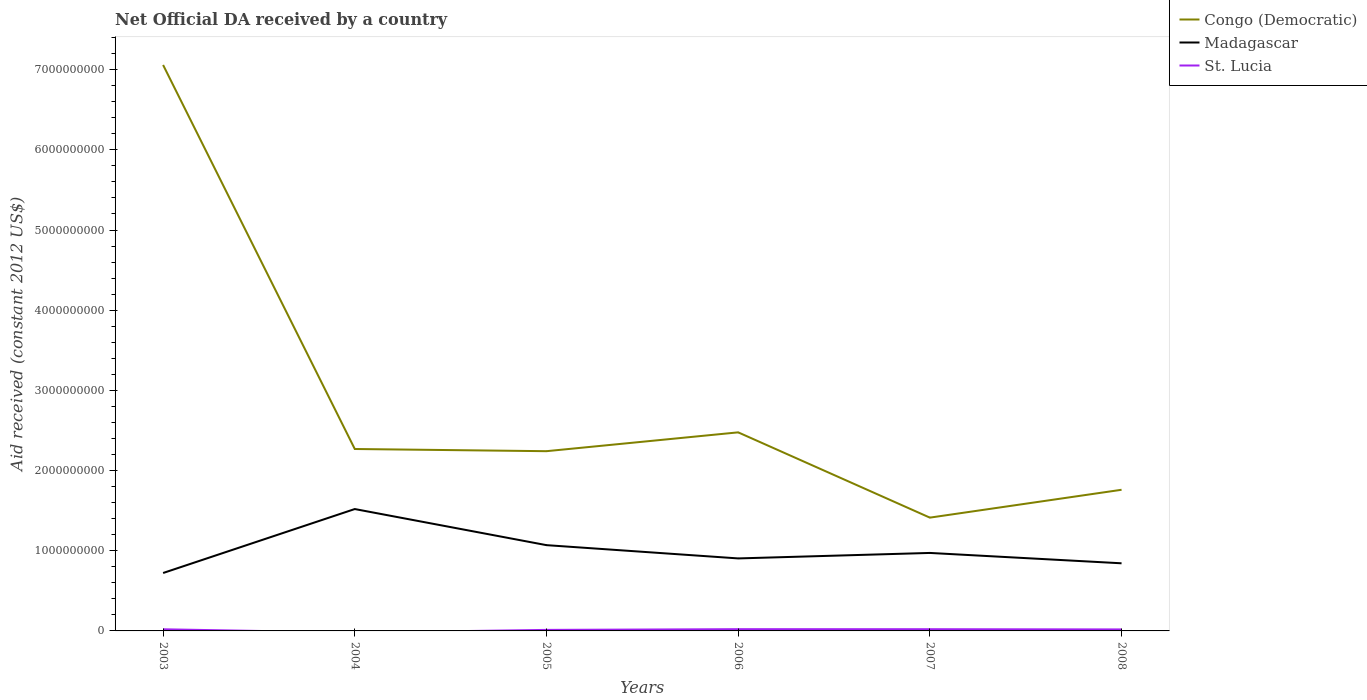How many different coloured lines are there?
Your answer should be compact. 3. Is the number of lines equal to the number of legend labels?
Give a very brief answer. No. Across all years, what is the maximum net official development assistance aid received in Madagascar?
Make the answer very short. 7.22e+08. What is the total net official development assistance aid received in Congo (Democratic) in the graph?
Offer a terse response. 4.79e+09. What is the difference between the highest and the second highest net official development assistance aid received in St. Lucia?
Provide a short and direct response. 2.18e+07. How many years are there in the graph?
Ensure brevity in your answer.  6. What is the difference between two consecutive major ticks on the Y-axis?
Give a very brief answer. 1.00e+09. Are the values on the major ticks of Y-axis written in scientific E-notation?
Keep it short and to the point. No. Where does the legend appear in the graph?
Keep it short and to the point. Top right. How many legend labels are there?
Offer a terse response. 3. How are the legend labels stacked?
Provide a short and direct response. Vertical. What is the title of the graph?
Provide a short and direct response. Net Official DA received by a country. What is the label or title of the Y-axis?
Provide a short and direct response. Aid received (constant 2012 US$). What is the Aid received (constant 2012 US$) in Congo (Democratic) in 2003?
Ensure brevity in your answer.  7.06e+09. What is the Aid received (constant 2012 US$) of Madagascar in 2003?
Offer a terse response. 7.22e+08. What is the Aid received (constant 2012 US$) of St. Lucia in 2003?
Offer a terse response. 2.05e+07. What is the Aid received (constant 2012 US$) of Congo (Democratic) in 2004?
Your answer should be very brief. 2.27e+09. What is the Aid received (constant 2012 US$) of Madagascar in 2004?
Your response must be concise. 1.52e+09. What is the Aid received (constant 2012 US$) of Congo (Democratic) in 2005?
Ensure brevity in your answer.  2.24e+09. What is the Aid received (constant 2012 US$) in Madagascar in 2005?
Make the answer very short. 1.07e+09. What is the Aid received (constant 2012 US$) in St. Lucia in 2005?
Provide a short and direct response. 1.29e+07. What is the Aid received (constant 2012 US$) of Congo (Democratic) in 2006?
Your answer should be compact. 2.48e+09. What is the Aid received (constant 2012 US$) in Madagascar in 2006?
Your response must be concise. 9.04e+08. What is the Aid received (constant 2012 US$) in St. Lucia in 2006?
Provide a short and direct response. 2.18e+07. What is the Aid received (constant 2012 US$) in Congo (Democratic) in 2007?
Ensure brevity in your answer.  1.41e+09. What is the Aid received (constant 2012 US$) of Madagascar in 2007?
Make the answer very short. 9.73e+08. What is the Aid received (constant 2012 US$) in St. Lucia in 2007?
Provide a succinct answer. 2.13e+07. What is the Aid received (constant 2012 US$) in Congo (Democratic) in 2008?
Make the answer very short. 1.76e+09. What is the Aid received (constant 2012 US$) of Madagascar in 2008?
Keep it short and to the point. 8.43e+08. What is the Aid received (constant 2012 US$) in St. Lucia in 2008?
Provide a short and direct response. 1.87e+07. Across all years, what is the maximum Aid received (constant 2012 US$) in Congo (Democratic)?
Ensure brevity in your answer.  7.06e+09. Across all years, what is the maximum Aid received (constant 2012 US$) of Madagascar?
Give a very brief answer. 1.52e+09. Across all years, what is the maximum Aid received (constant 2012 US$) of St. Lucia?
Make the answer very short. 2.18e+07. Across all years, what is the minimum Aid received (constant 2012 US$) in Congo (Democratic)?
Provide a succinct answer. 1.41e+09. Across all years, what is the minimum Aid received (constant 2012 US$) in Madagascar?
Keep it short and to the point. 7.22e+08. What is the total Aid received (constant 2012 US$) in Congo (Democratic) in the graph?
Offer a terse response. 1.72e+1. What is the total Aid received (constant 2012 US$) of Madagascar in the graph?
Ensure brevity in your answer.  6.03e+09. What is the total Aid received (constant 2012 US$) in St. Lucia in the graph?
Offer a terse response. 9.53e+07. What is the difference between the Aid received (constant 2012 US$) of Congo (Democratic) in 2003 and that in 2004?
Your response must be concise. 4.79e+09. What is the difference between the Aid received (constant 2012 US$) of Madagascar in 2003 and that in 2004?
Make the answer very short. -7.98e+08. What is the difference between the Aid received (constant 2012 US$) in Congo (Democratic) in 2003 and that in 2005?
Ensure brevity in your answer.  4.82e+09. What is the difference between the Aid received (constant 2012 US$) in Madagascar in 2003 and that in 2005?
Your response must be concise. -3.47e+08. What is the difference between the Aid received (constant 2012 US$) of St. Lucia in 2003 and that in 2005?
Offer a terse response. 7.64e+06. What is the difference between the Aid received (constant 2012 US$) in Congo (Democratic) in 2003 and that in 2006?
Your response must be concise. 4.58e+09. What is the difference between the Aid received (constant 2012 US$) of Madagascar in 2003 and that in 2006?
Provide a short and direct response. -1.82e+08. What is the difference between the Aid received (constant 2012 US$) of St. Lucia in 2003 and that in 2006?
Your response must be concise. -1.27e+06. What is the difference between the Aid received (constant 2012 US$) in Congo (Democratic) in 2003 and that in 2007?
Offer a terse response. 5.65e+09. What is the difference between the Aid received (constant 2012 US$) in Madagascar in 2003 and that in 2007?
Offer a terse response. -2.50e+08. What is the difference between the Aid received (constant 2012 US$) in St. Lucia in 2003 and that in 2007?
Give a very brief answer. -8.00e+05. What is the difference between the Aid received (constant 2012 US$) of Congo (Democratic) in 2003 and that in 2008?
Keep it short and to the point. 5.30e+09. What is the difference between the Aid received (constant 2012 US$) of Madagascar in 2003 and that in 2008?
Offer a terse response. -1.21e+08. What is the difference between the Aid received (constant 2012 US$) in St. Lucia in 2003 and that in 2008?
Your response must be concise. 1.85e+06. What is the difference between the Aid received (constant 2012 US$) in Congo (Democratic) in 2004 and that in 2005?
Provide a succinct answer. 2.72e+07. What is the difference between the Aid received (constant 2012 US$) in Madagascar in 2004 and that in 2005?
Offer a very short reply. 4.50e+08. What is the difference between the Aid received (constant 2012 US$) in Congo (Democratic) in 2004 and that in 2006?
Offer a very short reply. -2.08e+08. What is the difference between the Aid received (constant 2012 US$) in Madagascar in 2004 and that in 2006?
Give a very brief answer. 6.16e+08. What is the difference between the Aid received (constant 2012 US$) of Congo (Democratic) in 2004 and that in 2007?
Provide a short and direct response. 8.56e+08. What is the difference between the Aid received (constant 2012 US$) in Madagascar in 2004 and that in 2007?
Keep it short and to the point. 5.47e+08. What is the difference between the Aid received (constant 2012 US$) of Congo (Democratic) in 2004 and that in 2008?
Your response must be concise. 5.09e+08. What is the difference between the Aid received (constant 2012 US$) of Madagascar in 2004 and that in 2008?
Offer a terse response. 6.77e+08. What is the difference between the Aid received (constant 2012 US$) of Congo (Democratic) in 2005 and that in 2006?
Give a very brief answer. -2.35e+08. What is the difference between the Aid received (constant 2012 US$) of Madagascar in 2005 and that in 2006?
Offer a terse response. 1.65e+08. What is the difference between the Aid received (constant 2012 US$) of St. Lucia in 2005 and that in 2006?
Give a very brief answer. -8.91e+06. What is the difference between the Aid received (constant 2012 US$) of Congo (Democratic) in 2005 and that in 2007?
Provide a succinct answer. 8.29e+08. What is the difference between the Aid received (constant 2012 US$) of Madagascar in 2005 and that in 2007?
Make the answer very short. 9.71e+07. What is the difference between the Aid received (constant 2012 US$) of St. Lucia in 2005 and that in 2007?
Ensure brevity in your answer.  -8.44e+06. What is the difference between the Aid received (constant 2012 US$) in Congo (Democratic) in 2005 and that in 2008?
Keep it short and to the point. 4.81e+08. What is the difference between the Aid received (constant 2012 US$) in Madagascar in 2005 and that in 2008?
Provide a succinct answer. 2.26e+08. What is the difference between the Aid received (constant 2012 US$) of St. Lucia in 2005 and that in 2008?
Ensure brevity in your answer.  -5.79e+06. What is the difference between the Aid received (constant 2012 US$) in Congo (Democratic) in 2006 and that in 2007?
Ensure brevity in your answer.  1.06e+09. What is the difference between the Aid received (constant 2012 US$) in Madagascar in 2006 and that in 2007?
Your answer should be compact. -6.84e+07. What is the difference between the Aid received (constant 2012 US$) in Congo (Democratic) in 2006 and that in 2008?
Make the answer very short. 7.16e+08. What is the difference between the Aid received (constant 2012 US$) of Madagascar in 2006 and that in 2008?
Provide a succinct answer. 6.08e+07. What is the difference between the Aid received (constant 2012 US$) of St. Lucia in 2006 and that in 2008?
Offer a very short reply. 3.12e+06. What is the difference between the Aid received (constant 2012 US$) in Congo (Democratic) in 2007 and that in 2008?
Your response must be concise. -3.47e+08. What is the difference between the Aid received (constant 2012 US$) of Madagascar in 2007 and that in 2008?
Your answer should be very brief. 1.29e+08. What is the difference between the Aid received (constant 2012 US$) of St. Lucia in 2007 and that in 2008?
Give a very brief answer. 2.65e+06. What is the difference between the Aid received (constant 2012 US$) of Congo (Democratic) in 2003 and the Aid received (constant 2012 US$) of Madagascar in 2004?
Provide a succinct answer. 5.54e+09. What is the difference between the Aid received (constant 2012 US$) of Congo (Democratic) in 2003 and the Aid received (constant 2012 US$) of Madagascar in 2005?
Keep it short and to the point. 5.99e+09. What is the difference between the Aid received (constant 2012 US$) of Congo (Democratic) in 2003 and the Aid received (constant 2012 US$) of St. Lucia in 2005?
Offer a terse response. 7.05e+09. What is the difference between the Aid received (constant 2012 US$) of Madagascar in 2003 and the Aid received (constant 2012 US$) of St. Lucia in 2005?
Your answer should be very brief. 7.10e+08. What is the difference between the Aid received (constant 2012 US$) in Congo (Democratic) in 2003 and the Aid received (constant 2012 US$) in Madagascar in 2006?
Your answer should be compact. 6.15e+09. What is the difference between the Aid received (constant 2012 US$) of Congo (Democratic) in 2003 and the Aid received (constant 2012 US$) of St. Lucia in 2006?
Give a very brief answer. 7.04e+09. What is the difference between the Aid received (constant 2012 US$) in Madagascar in 2003 and the Aid received (constant 2012 US$) in St. Lucia in 2006?
Provide a succinct answer. 7.01e+08. What is the difference between the Aid received (constant 2012 US$) in Congo (Democratic) in 2003 and the Aid received (constant 2012 US$) in Madagascar in 2007?
Your response must be concise. 6.09e+09. What is the difference between the Aid received (constant 2012 US$) of Congo (Democratic) in 2003 and the Aid received (constant 2012 US$) of St. Lucia in 2007?
Your response must be concise. 7.04e+09. What is the difference between the Aid received (constant 2012 US$) in Madagascar in 2003 and the Aid received (constant 2012 US$) in St. Lucia in 2007?
Your response must be concise. 7.01e+08. What is the difference between the Aid received (constant 2012 US$) in Congo (Democratic) in 2003 and the Aid received (constant 2012 US$) in Madagascar in 2008?
Your response must be concise. 6.22e+09. What is the difference between the Aid received (constant 2012 US$) of Congo (Democratic) in 2003 and the Aid received (constant 2012 US$) of St. Lucia in 2008?
Your answer should be very brief. 7.04e+09. What is the difference between the Aid received (constant 2012 US$) in Madagascar in 2003 and the Aid received (constant 2012 US$) in St. Lucia in 2008?
Provide a short and direct response. 7.04e+08. What is the difference between the Aid received (constant 2012 US$) of Congo (Democratic) in 2004 and the Aid received (constant 2012 US$) of Madagascar in 2005?
Offer a terse response. 1.20e+09. What is the difference between the Aid received (constant 2012 US$) in Congo (Democratic) in 2004 and the Aid received (constant 2012 US$) in St. Lucia in 2005?
Ensure brevity in your answer.  2.26e+09. What is the difference between the Aid received (constant 2012 US$) in Madagascar in 2004 and the Aid received (constant 2012 US$) in St. Lucia in 2005?
Your answer should be very brief. 1.51e+09. What is the difference between the Aid received (constant 2012 US$) in Congo (Democratic) in 2004 and the Aid received (constant 2012 US$) in Madagascar in 2006?
Ensure brevity in your answer.  1.36e+09. What is the difference between the Aid received (constant 2012 US$) in Congo (Democratic) in 2004 and the Aid received (constant 2012 US$) in St. Lucia in 2006?
Make the answer very short. 2.25e+09. What is the difference between the Aid received (constant 2012 US$) in Madagascar in 2004 and the Aid received (constant 2012 US$) in St. Lucia in 2006?
Offer a terse response. 1.50e+09. What is the difference between the Aid received (constant 2012 US$) in Congo (Democratic) in 2004 and the Aid received (constant 2012 US$) in Madagascar in 2007?
Keep it short and to the point. 1.30e+09. What is the difference between the Aid received (constant 2012 US$) of Congo (Democratic) in 2004 and the Aid received (constant 2012 US$) of St. Lucia in 2007?
Offer a terse response. 2.25e+09. What is the difference between the Aid received (constant 2012 US$) of Madagascar in 2004 and the Aid received (constant 2012 US$) of St. Lucia in 2007?
Give a very brief answer. 1.50e+09. What is the difference between the Aid received (constant 2012 US$) in Congo (Democratic) in 2004 and the Aid received (constant 2012 US$) in Madagascar in 2008?
Provide a short and direct response. 1.43e+09. What is the difference between the Aid received (constant 2012 US$) in Congo (Democratic) in 2004 and the Aid received (constant 2012 US$) in St. Lucia in 2008?
Offer a very short reply. 2.25e+09. What is the difference between the Aid received (constant 2012 US$) of Madagascar in 2004 and the Aid received (constant 2012 US$) of St. Lucia in 2008?
Ensure brevity in your answer.  1.50e+09. What is the difference between the Aid received (constant 2012 US$) in Congo (Democratic) in 2005 and the Aid received (constant 2012 US$) in Madagascar in 2006?
Provide a short and direct response. 1.34e+09. What is the difference between the Aid received (constant 2012 US$) in Congo (Democratic) in 2005 and the Aid received (constant 2012 US$) in St. Lucia in 2006?
Provide a succinct answer. 2.22e+09. What is the difference between the Aid received (constant 2012 US$) in Madagascar in 2005 and the Aid received (constant 2012 US$) in St. Lucia in 2006?
Provide a short and direct response. 1.05e+09. What is the difference between the Aid received (constant 2012 US$) of Congo (Democratic) in 2005 and the Aid received (constant 2012 US$) of Madagascar in 2007?
Provide a succinct answer. 1.27e+09. What is the difference between the Aid received (constant 2012 US$) of Congo (Democratic) in 2005 and the Aid received (constant 2012 US$) of St. Lucia in 2007?
Your answer should be compact. 2.22e+09. What is the difference between the Aid received (constant 2012 US$) of Madagascar in 2005 and the Aid received (constant 2012 US$) of St. Lucia in 2007?
Your response must be concise. 1.05e+09. What is the difference between the Aid received (constant 2012 US$) of Congo (Democratic) in 2005 and the Aid received (constant 2012 US$) of Madagascar in 2008?
Your answer should be very brief. 1.40e+09. What is the difference between the Aid received (constant 2012 US$) of Congo (Democratic) in 2005 and the Aid received (constant 2012 US$) of St. Lucia in 2008?
Keep it short and to the point. 2.22e+09. What is the difference between the Aid received (constant 2012 US$) in Madagascar in 2005 and the Aid received (constant 2012 US$) in St. Lucia in 2008?
Offer a terse response. 1.05e+09. What is the difference between the Aid received (constant 2012 US$) of Congo (Democratic) in 2006 and the Aid received (constant 2012 US$) of Madagascar in 2007?
Offer a terse response. 1.50e+09. What is the difference between the Aid received (constant 2012 US$) of Congo (Democratic) in 2006 and the Aid received (constant 2012 US$) of St. Lucia in 2007?
Ensure brevity in your answer.  2.46e+09. What is the difference between the Aid received (constant 2012 US$) in Madagascar in 2006 and the Aid received (constant 2012 US$) in St. Lucia in 2007?
Ensure brevity in your answer.  8.83e+08. What is the difference between the Aid received (constant 2012 US$) in Congo (Democratic) in 2006 and the Aid received (constant 2012 US$) in Madagascar in 2008?
Offer a very short reply. 1.63e+09. What is the difference between the Aid received (constant 2012 US$) in Congo (Democratic) in 2006 and the Aid received (constant 2012 US$) in St. Lucia in 2008?
Your response must be concise. 2.46e+09. What is the difference between the Aid received (constant 2012 US$) in Madagascar in 2006 and the Aid received (constant 2012 US$) in St. Lucia in 2008?
Offer a very short reply. 8.86e+08. What is the difference between the Aid received (constant 2012 US$) in Congo (Democratic) in 2007 and the Aid received (constant 2012 US$) in Madagascar in 2008?
Your response must be concise. 5.70e+08. What is the difference between the Aid received (constant 2012 US$) in Congo (Democratic) in 2007 and the Aid received (constant 2012 US$) in St. Lucia in 2008?
Your answer should be compact. 1.39e+09. What is the difference between the Aid received (constant 2012 US$) in Madagascar in 2007 and the Aid received (constant 2012 US$) in St. Lucia in 2008?
Your answer should be very brief. 9.54e+08. What is the average Aid received (constant 2012 US$) of Congo (Democratic) per year?
Your response must be concise. 2.87e+09. What is the average Aid received (constant 2012 US$) in Madagascar per year?
Your answer should be very brief. 1.01e+09. What is the average Aid received (constant 2012 US$) in St. Lucia per year?
Make the answer very short. 1.59e+07. In the year 2003, what is the difference between the Aid received (constant 2012 US$) in Congo (Democratic) and Aid received (constant 2012 US$) in Madagascar?
Offer a very short reply. 6.34e+09. In the year 2003, what is the difference between the Aid received (constant 2012 US$) in Congo (Democratic) and Aid received (constant 2012 US$) in St. Lucia?
Provide a short and direct response. 7.04e+09. In the year 2003, what is the difference between the Aid received (constant 2012 US$) in Madagascar and Aid received (constant 2012 US$) in St. Lucia?
Offer a terse response. 7.02e+08. In the year 2004, what is the difference between the Aid received (constant 2012 US$) in Congo (Democratic) and Aid received (constant 2012 US$) in Madagascar?
Offer a terse response. 7.49e+08. In the year 2005, what is the difference between the Aid received (constant 2012 US$) of Congo (Democratic) and Aid received (constant 2012 US$) of Madagascar?
Your answer should be compact. 1.17e+09. In the year 2005, what is the difference between the Aid received (constant 2012 US$) in Congo (Democratic) and Aid received (constant 2012 US$) in St. Lucia?
Give a very brief answer. 2.23e+09. In the year 2005, what is the difference between the Aid received (constant 2012 US$) in Madagascar and Aid received (constant 2012 US$) in St. Lucia?
Your answer should be very brief. 1.06e+09. In the year 2006, what is the difference between the Aid received (constant 2012 US$) of Congo (Democratic) and Aid received (constant 2012 US$) of Madagascar?
Your answer should be very brief. 1.57e+09. In the year 2006, what is the difference between the Aid received (constant 2012 US$) in Congo (Democratic) and Aid received (constant 2012 US$) in St. Lucia?
Make the answer very short. 2.45e+09. In the year 2006, what is the difference between the Aid received (constant 2012 US$) in Madagascar and Aid received (constant 2012 US$) in St. Lucia?
Your response must be concise. 8.82e+08. In the year 2007, what is the difference between the Aid received (constant 2012 US$) of Congo (Democratic) and Aid received (constant 2012 US$) of Madagascar?
Make the answer very short. 4.40e+08. In the year 2007, what is the difference between the Aid received (constant 2012 US$) of Congo (Democratic) and Aid received (constant 2012 US$) of St. Lucia?
Make the answer very short. 1.39e+09. In the year 2007, what is the difference between the Aid received (constant 2012 US$) in Madagascar and Aid received (constant 2012 US$) in St. Lucia?
Give a very brief answer. 9.51e+08. In the year 2008, what is the difference between the Aid received (constant 2012 US$) in Congo (Democratic) and Aid received (constant 2012 US$) in Madagascar?
Make the answer very short. 9.17e+08. In the year 2008, what is the difference between the Aid received (constant 2012 US$) in Congo (Democratic) and Aid received (constant 2012 US$) in St. Lucia?
Your response must be concise. 1.74e+09. In the year 2008, what is the difference between the Aid received (constant 2012 US$) in Madagascar and Aid received (constant 2012 US$) in St. Lucia?
Your answer should be very brief. 8.25e+08. What is the ratio of the Aid received (constant 2012 US$) of Congo (Democratic) in 2003 to that in 2004?
Keep it short and to the point. 3.11. What is the ratio of the Aid received (constant 2012 US$) of Madagascar in 2003 to that in 2004?
Your answer should be very brief. 0.48. What is the ratio of the Aid received (constant 2012 US$) in Congo (Democratic) in 2003 to that in 2005?
Provide a short and direct response. 3.15. What is the ratio of the Aid received (constant 2012 US$) of Madagascar in 2003 to that in 2005?
Provide a short and direct response. 0.68. What is the ratio of the Aid received (constant 2012 US$) of St. Lucia in 2003 to that in 2005?
Your response must be concise. 1.59. What is the ratio of the Aid received (constant 2012 US$) of Congo (Democratic) in 2003 to that in 2006?
Provide a succinct answer. 2.85. What is the ratio of the Aid received (constant 2012 US$) of Madagascar in 2003 to that in 2006?
Offer a very short reply. 0.8. What is the ratio of the Aid received (constant 2012 US$) in St. Lucia in 2003 to that in 2006?
Offer a terse response. 0.94. What is the ratio of the Aid received (constant 2012 US$) in Congo (Democratic) in 2003 to that in 2007?
Provide a short and direct response. 5. What is the ratio of the Aid received (constant 2012 US$) of Madagascar in 2003 to that in 2007?
Give a very brief answer. 0.74. What is the ratio of the Aid received (constant 2012 US$) of St. Lucia in 2003 to that in 2007?
Your answer should be very brief. 0.96. What is the ratio of the Aid received (constant 2012 US$) in Congo (Democratic) in 2003 to that in 2008?
Provide a succinct answer. 4.01. What is the ratio of the Aid received (constant 2012 US$) in Madagascar in 2003 to that in 2008?
Ensure brevity in your answer.  0.86. What is the ratio of the Aid received (constant 2012 US$) of St. Lucia in 2003 to that in 2008?
Keep it short and to the point. 1.1. What is the ratio of the Aid received (constant 2012 US$) of Congo (Democratic) in 2004 to that in 2005?
Make the answer very short. 1.01. What is the ratio of the Aid received (constant 2012 US$) in Madagascar in 2004 to that in 2005?
Your response must be concise. 1.42. What is the ratio of the Aid received (constant 2012 US$) of Congo (Democratic) in 2004 to that in 2006?
Ensure brevity in your answer.  0.92. What is the ratio of the Aid received (constant 2012 US$) of Madagascar in 2004 to that in 2006?
Your response must be concise. 1.68. What is the ratio of the Aid received (constant 2012 US$) of Congo (Democratic) in 2004 to that in 2007?
Offer a terse response. 1.61. What is the ratio of the Aid received (constant 2012 US$) in Madagascar in 2004 to that in 2007?
Your response must be concise. 1.56. What is the ratio of the Aid received (constant 2012 US$) in Congo (Democratic) in 2004 to that in 2008?
Make the answer very short. 1.29. What is the ratio of the Aid received (constant 2012 US$) of Madagascar in 2004 to that in 2008?
Your response must be concise. 1.8. What is the ratio of the Aid received (constant 2012 US$) of Congo (Democratic) in 2005 to that in 2006?
Provide a succinct answer. 0.91. What is the ratio of the Aid received (constant 2012 US$) of Madagascar in 2005 to that in 2006?
Your response must be concise. 1.18. What is the ratio of the Aid received (constant 2012 US$) of St. Lucia in 2005 to that in 2006?
Ensure brevity in your answer.  0.59. What is the ratio of the Aid received (constant 2012 US$) of Congo (Democratic) in 2005 to that in 2007?
Keep it short and to the point. 1.59. What is the ratio of the Aid received (constant 2012 US$) in Madagascar in 2005 to that in 2007?
Provide a short and direct response. 1.1. What is the ratio of the Aid received (constant 2012 US$) of St. Lucia in 2005 to that in 2007?
Keep it short and to the point. 0.6. What is the ratio of the Aid received (constant 2012 US$) in Congo (Democratic) in 2005 to that in 2008?
Keep it short and to the point. 1.27. What is the ratio of the Aid received (constant 2012 US$) of Madagascar in 2005 to that in 2008?
Give a very brief answer. 1.27. What is the ratio of the Aid received (constant 2012 US$) in St. Lucia in 2005 to that in 2008?
Your answer should be compact. 0.69. What is the ratio of the Aid received (constant 2012 US$) in Congo (Democratic) in 2006 to that in 2007?
Your answer should be very brief. 1.75. What is the ratio of the Aid received (constant 2012 US$) in Madagascar in 2006 to that in 2007?
Offer a terse response. 0.93. What is the ratio of the Aid received (constant 2012 US$) in Congo (Democratic) in 2006 to that in 2008?
Your answer should be very brief. 1.41. What is the ratio of the Aid received (constant 2012 US$) in Madagascar in 2006 to that in 2008?
Offer a terse response. 1.07. What is the ratio of the Aid received (constant 2012 US$) in St. Lucia in 2006 to that in 2008?
Offer a very short reply. 1.17. What is the ratio of the Aid received (constant 2012 US$) in Congo (Democratic) in 2007 to that in 2008?
Your response must be concise. 0.8. What is the ratio of the Aid received (constant 2012 US$) of Madagascar in 2007 to that in 2008?
Give a very brief answer. 1.15. What is the ratio of the Aid received (constant 2012 US$) in St. Lucia in 2007 to that in 2008?
Offer a terse response. 1.14. What is the difference between the highest and the second highest Aid received (constant 2012 US$) of Congo (Democratic)?
Keep it short and to the point. 4.58e+09. What is the difference between the highest and the second highest Aid received (constant 2012 US$) in Madagascar?
Give a very brief answer. 4.50e+08. What is the difference between the highest and the lowest Aid received (constant 2012 US$) of Congo (Democratic)?
Your answer should be very brief. 5.65e+09. What is the difference between the highest and the lowest Aid received (constant 2012 US$) of Madagascar?
Make the answer very short. 7.98e+08. What is the difference between the highest and the lowest Aid received (constant 2012 US$) of St. Lucia?
Make the answer very short. 2.18e+07. 